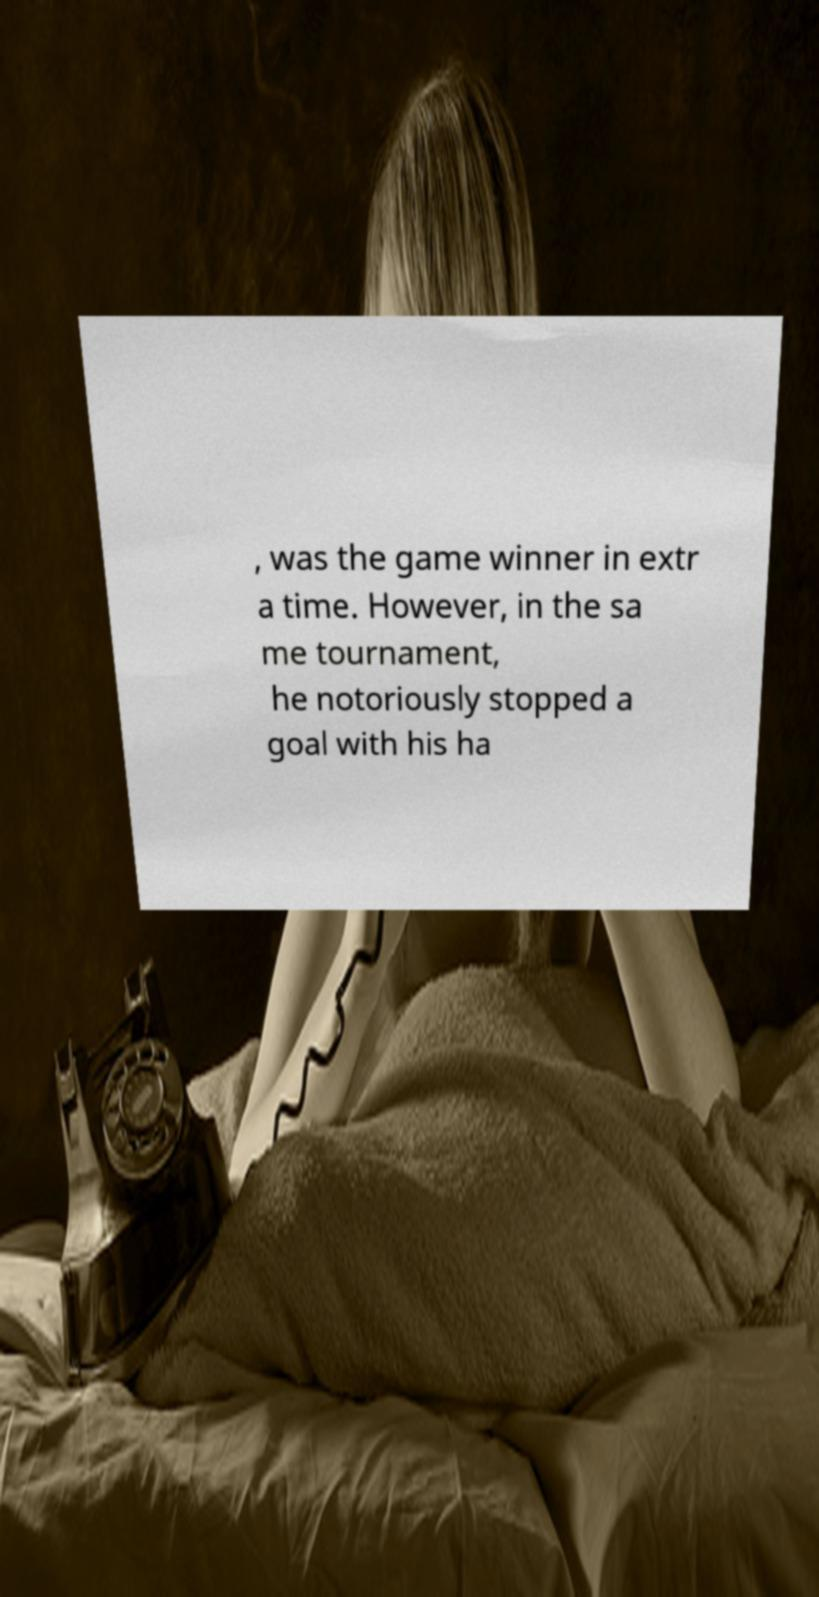There's text embedded in this image that I need extracted. Can you transcribe it verbatim? , was the game winner in extr a time. However, in the sa me tournament, he notoriously stopped a goal with his ha 